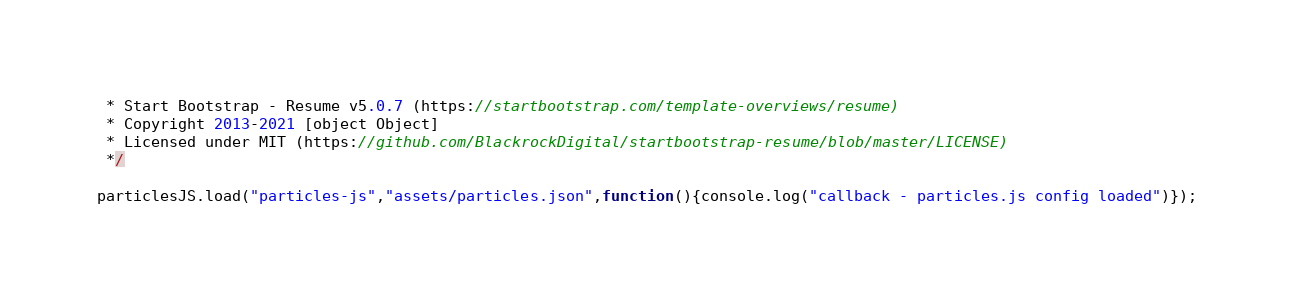Convert code to text. <code><loc_0><loc_0><loc_500><loc_500><_JavaScript_> * Start Bootstrap - Resume v5.0.7 (https://startbootstrap.com/template-overviews/resume)
 * Copyright 2013-2021 [object Object]
 * Licensed under MIT (https://github.com/BlackrockDigital/startbootstrap-resume/blob/master/LICENSE)
 */

particlesJS.load("particles-js","assets/particles.json",function(){console.log("callback - particles.js config loaded")});</code> 